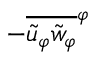<formula> <loc_0><loc_0><loc_500><loc_500>- \overline { { \tilde { u } _ { \varphi } \tilde { w } _ { \varphi } } } ^ { \varphi }</formula> 